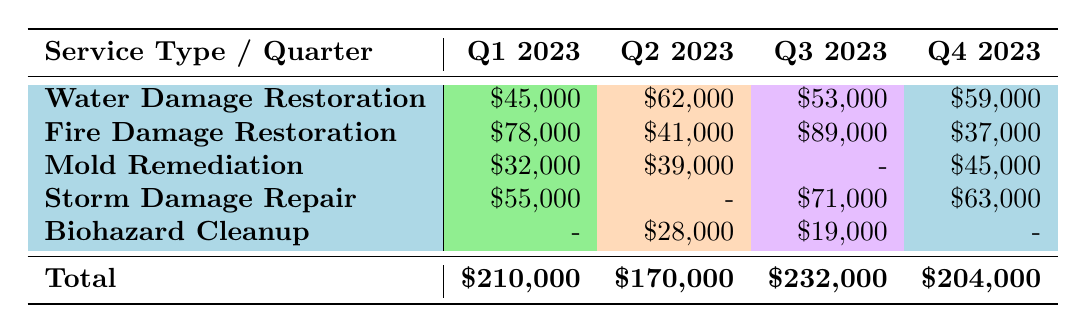What was the highest revenue from Water Damage Restoration in any quarter? Looking at the Water Damage Restoration row, the revenues for each quarter are $45,000 (Q1 2023), $62,000 (Q2 2023), $53,000 (Q3 2023), and $59,000 (Q4 2023). The highest value is $62,000 in Q2 2023.
Answer: $62,000 Which quarter had the lowest total revenue? The total revenues for each quarter are $210,000 (Q1 2023), $170,000 (Q2 2023), $232,000 (Q3 2023), and $204,000 (Q4 2023). The lowest revenue total is $170,000 in Q2 2023.
Answer: Q2 2023 Is there a quarter where Biohazard Cleanup had no revenue? In the Biohazard Cleanup row, there are values for Q2 2023 ($28,000) and Q3 2023 ($19,000), but there are no revenue entries for Q1 2023 and Q4 2023. Thus, it is true that there were quarters without revenue for Biohazard Cleanup.
Answer: Yes What is the difference in revenue between Fire Damage Restoration in Q1 2023 and Q4 2023? The revenues for Fire Damage Restoration are $78,000 in Q1 2023 and $37,000 in Q4 2023. The difference is calculated as $78,000 - $37,000 = $41,000.
Answer: $41,000 What is the total revenue for Mold Remediation across all quarters? The revenues listed for Mold Remediation are $32,000 (Q1 2023), $39,000 (Q2 2023), and $45,000 (Q4 2023). Q3 2023 has no revenue listed. Therefore, the total is $32,000 + $39,000 + $45,000 = $116,000.
Answer: $116,000 In which quarter did Fire Damage Restoration generate the highest revenue? Looking at the Fire Damage Restoration row, the revenues by quarter are $78,000 (Q1 2023), $41,000 (Q2 2023), $89,000 (Q3 2023), and $37,000 (Q4 2023). The highest revenue was in Q3 2023 with $89,000.
Answer: Q3 2023 What is the average revenue for Storm Damage Repair across the quarters it was provided? The revenues for Storm Damage Repair are $55,000 (Q1 2023), $71,000 (Q3 2023), and $63,000 (Q4 2023). Since there is no revenue for Q2 2023, we calculate the average as follows: (55,000 + 71,000 + 63,000) / 3 = $63,000.
Answer: $63,000 Was there any quarter with no recorded revenue for Fire Damage Restoration? The values for Fire Damage Restoration are $78,000 (Q1 2023), $41,000 (Q2 2023), $89,000 (Q3 2023), and $37,000 (Q4 2023). Since all quarters have revenue recorded, the answer is no.
Answer: No 